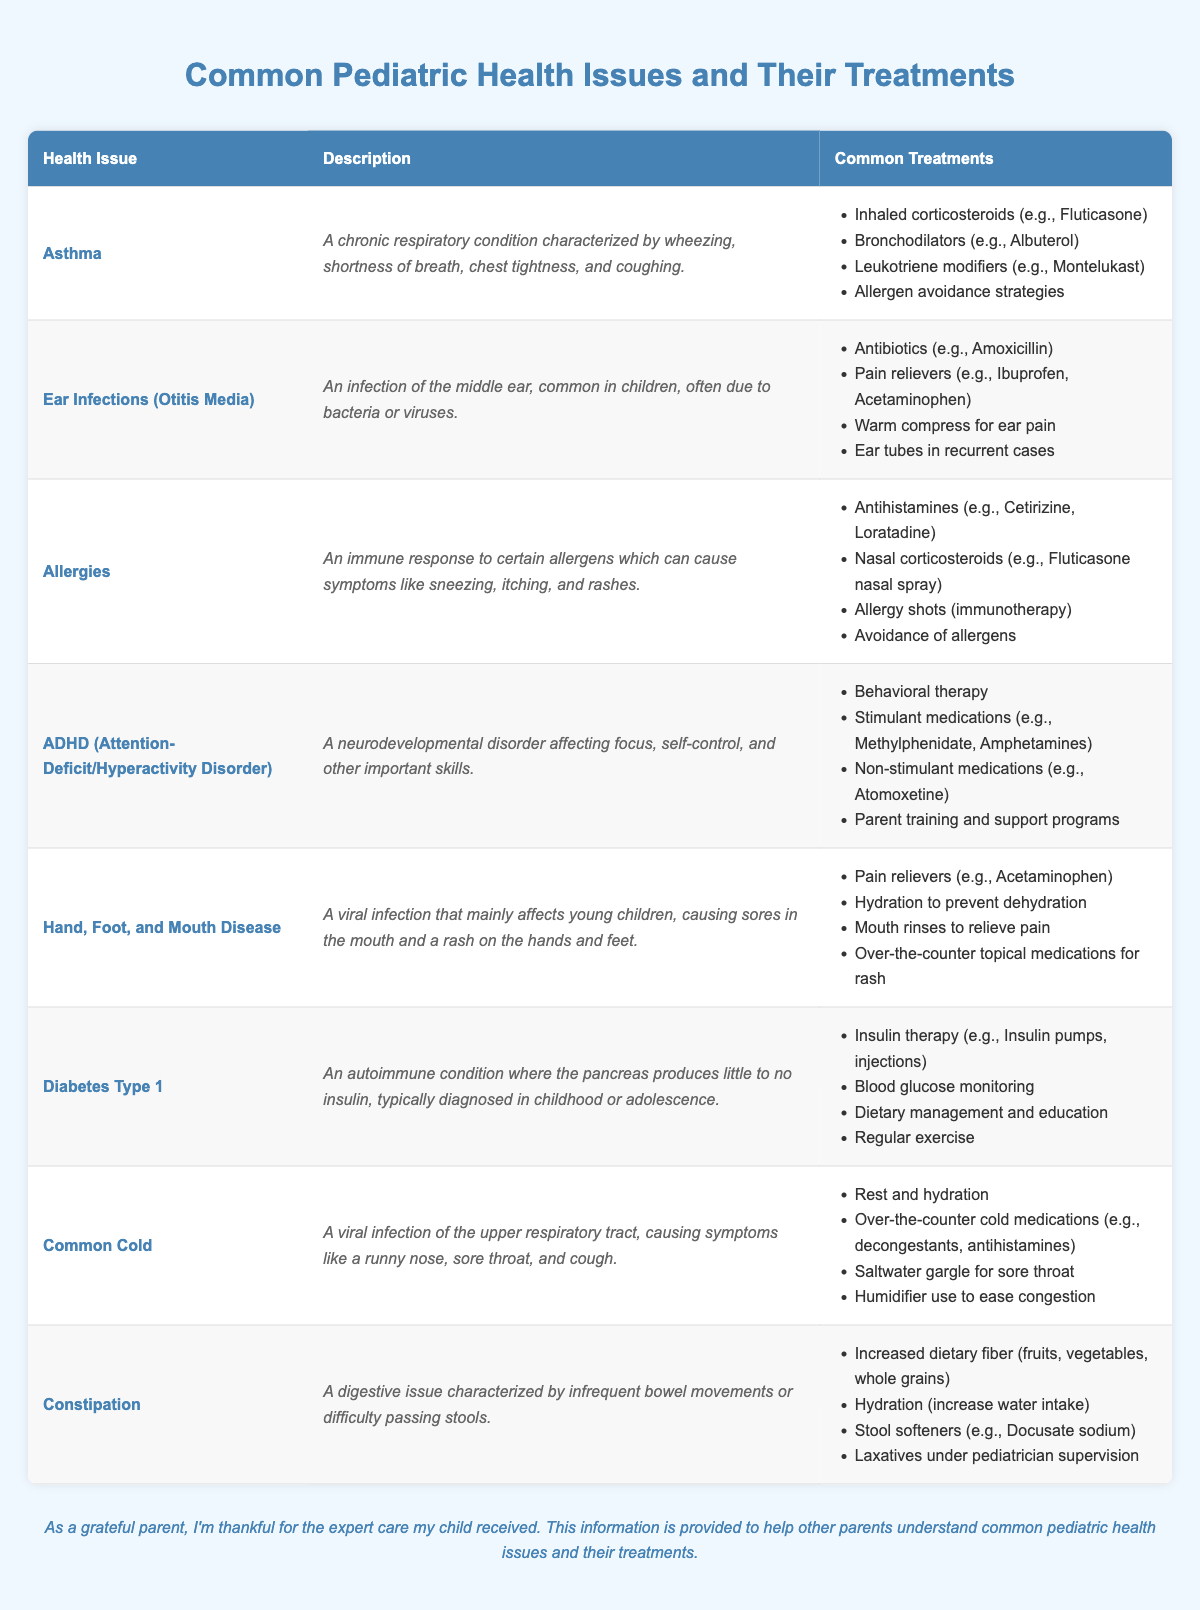What is a common treatment for asthma? The table lists inhaled corticosteroids (e.g., Fluticasone) as a common treatment for asthma.
Answer: Inhaled corticosteroids Which health issue describes an immune response causing sneezing and rashes? The description for allergies states it is an immune response to certain allergens, leading to sneezing, itching, and rashes.
Answer: Allergies How many treatments are listed for common colds? The table shows four treatments listed for the common cold: rest and hydration, over-the-counter cold medications, saltwater gargle, and humidifier use, totaling four treatments.
Answer: Four treatments Are antibiotics a treatment option for hand, foot, and mouth disease? The table does not list antibiotics as a treatment for hand, foot, and mouth disease, indicating they are not a treatment option for this condition.
Answer: No Which treatment for diabetes type 1 focuses on monitoring? Blood glucose monitoring is specifically mentioned as a treatment for diabetes type 1, highlighting its importance in managing the condition.
Answer: Blood glucose monitoring What is the relationship between increased dietary fiber and constipation treatment? Increased dietary fiber helps treat constipation by promoting regular bowel movements, indicated in the table containing dietary recommendations.
Answer: Helps treat constipation What is the main characteristic of ADHD according to the table? ADHD is described as a neurodevelopmental disorder affecting focus, self-control, and important skills.
Answer: A neurodevelopmental disorder Is it true that hydration is important for both hand, foot, and mouth disease and constipation? Yes, hydration is listed as an important treatment for preventing dehydration in hand, foot, and mouth disease and increasing water intake for constipation.
Answer: Yes What are the primary components of treatment for ear infections? The treatments listed for ear infections include antibiotics, pain relievers, warm compresses, and ear tubes in recurrent cases, combining them gives a comprehensive understanding of the treatment options.
Answer: Antibiotics, pain relievers, warm compresses, ear tubes If a child has a respiratory condition, which treatment from the table should they receive? The common treatments for a respiratory condition like asthma include inhaled corticosteroids and bronchodilators, hence they should receive those treatment options.
Answer: Inhaled corticosteroids or bronchodilators 